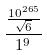Convert formula to latex. <formula><loc_0><loc_0><loc_500><loc_500>\frac { \frac { 1 0 ^ { 2 6 5 } } { \sqrt { 6 } } } { 1 ^ { 9 } }</formula> 